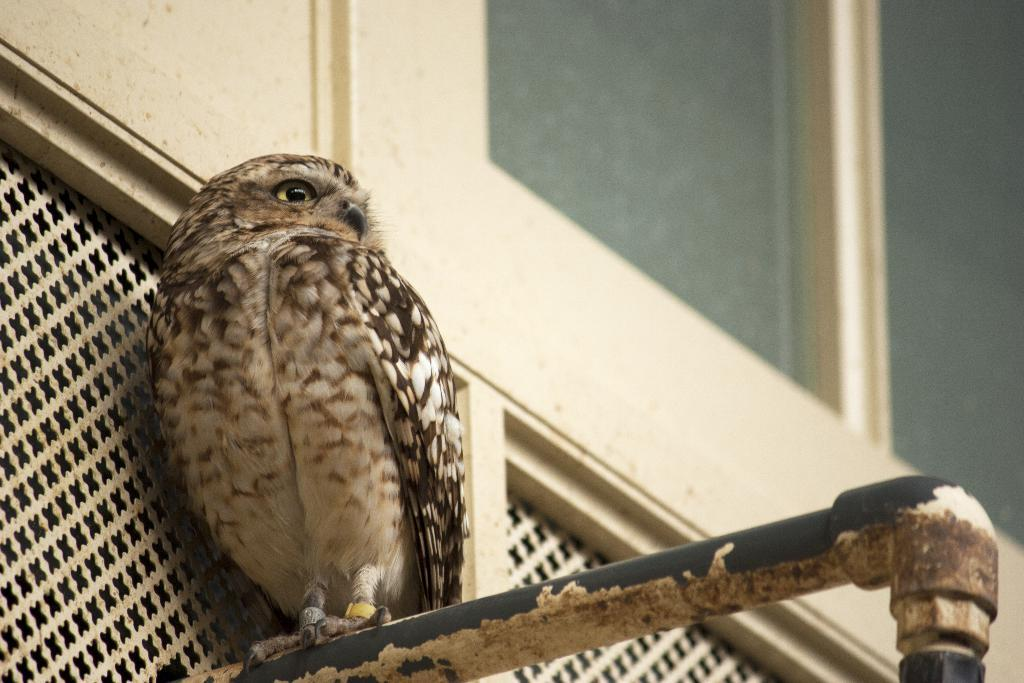What animal is present in the image? There is an owl in the image. Where is the owl located? The owl is on an iron pipe. What type of background can be seen in the image? There is a white wall in the image. Are there any openings visible in the wall? Yes, there are windows visible in the image. How many owls are part of the flock in the image? There is only one owl present in the image, so there is no flock. What season is depicted in the image? The image does not provide any information about the season, so it cannot be determined. 